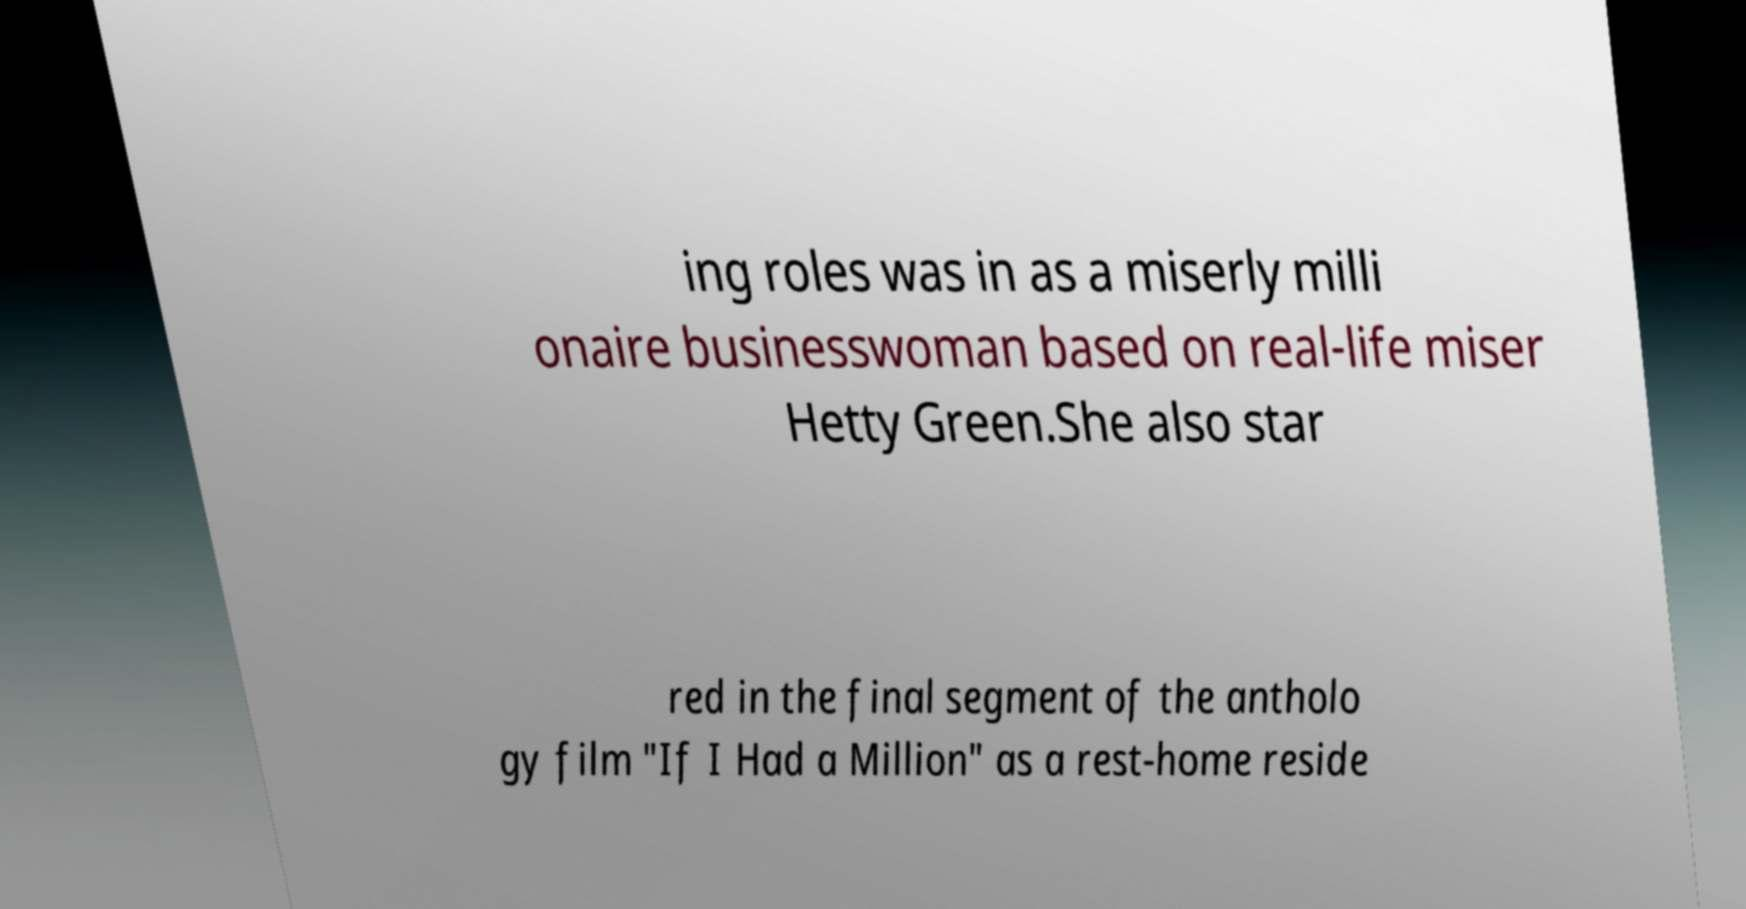For documentation purposes, I need the text within this image transcribed. Could you provide that? ing roles was in as a miserly milli onaire businesswoman based on real-life miser Hetty Green.She also star red in the final segment of the antholo gy film "If I Had a Million" as a rest-home reside 